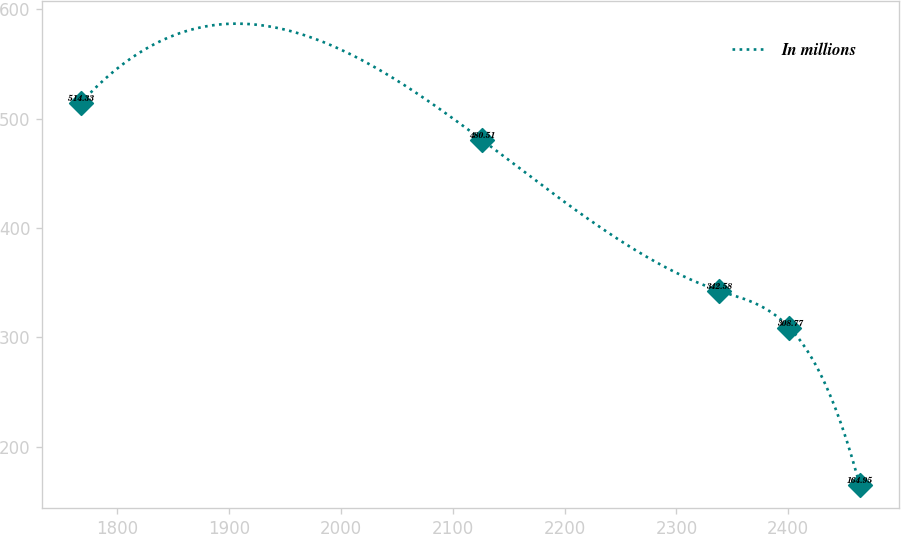Convert chart. <chart><loc_0><loc_0><loc_500><loc_500><line_chart><ecel><fcel>In millions<nl><fcel>1767.44<fcel>514.33<nl><fcel>2126.15<fcel>480.51<nl><fcel>2338.2<fcel>342.58<nl><fcel>2401.02<fcel>308.77<nl><fcel>2463.84<fcel>164.95<nl></chart> 